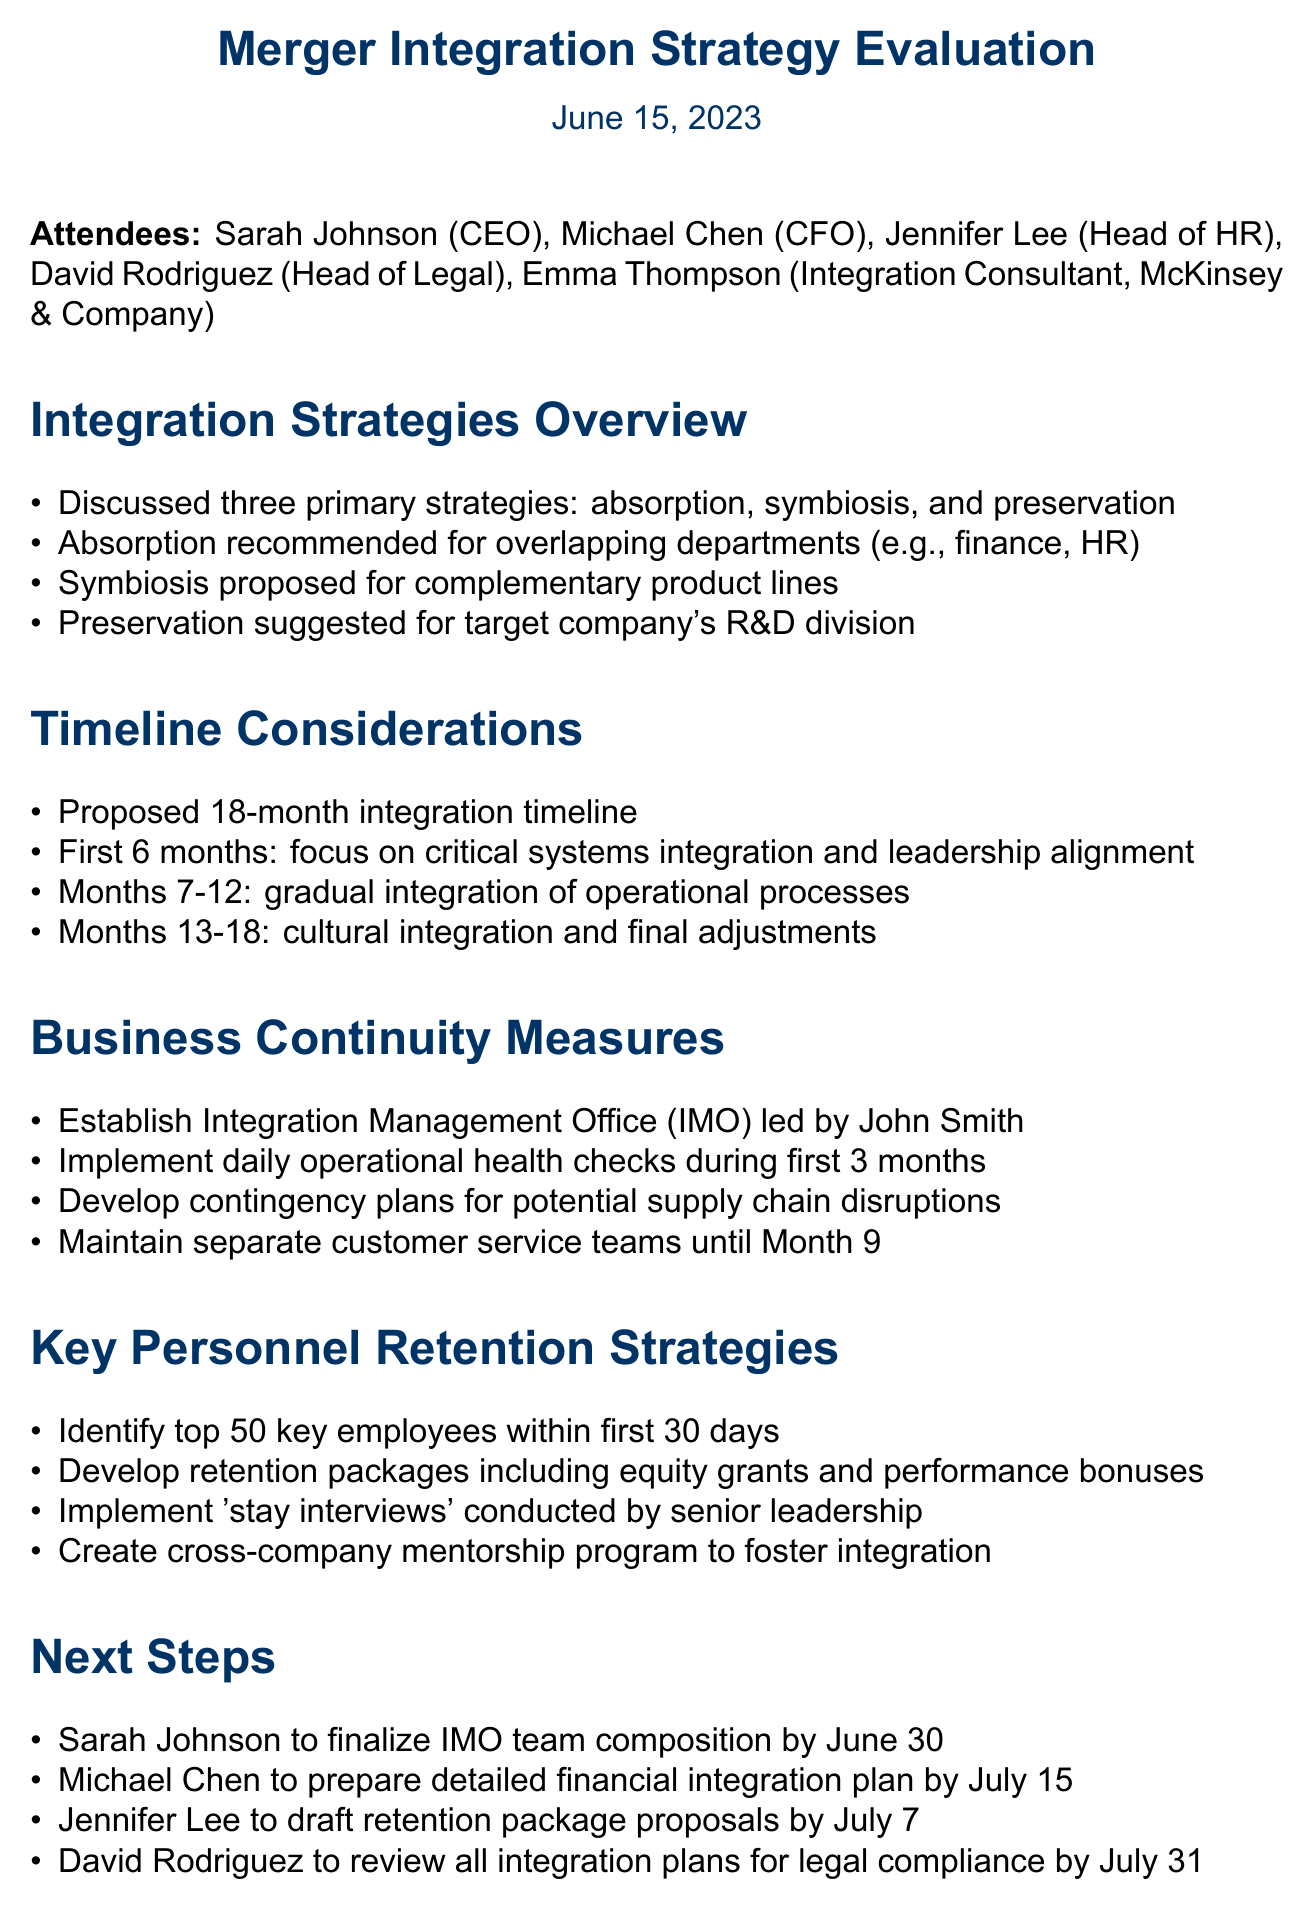what is the meeting title? The meeting title is stated at the beginning of the document as the focus of discussion and provides context.
Answer: Merger Integration Strategy Evaluation who led the Integration Management Office? The document specifies that John Smith is responsible for leading the Integration Management Office, which is crucial for overseeing the integration.
Answer: John Smith what is the proposed integration timeline? The document outlines a timeframe for integration, reflecting the planned steps for merging operations.
Answer: 18 months how many key employees are to be identified? The document mentions a specific number of key employees to focus on for retention, which is essential for maintaining business continuity.
Answer: 50 when is the retention package proposals draft due? The next steps include a deadline for submitting proposals related to retaining key personnel, indicating the urgency of the matter.
Answer: July 7 what are the three primary integration strategies discussed? The document lists the strategies recommended for integration, showcasing the approach to merging the two companies effectively.
Answer: absorption, symbiosis, preservation what is the focus during the first 6 months of integration? The document highlights the initial phase of integration and what themes will dominate those early efforts to ensure smooth operations.
Answer: critical systems integration and leadership alignment what is included in the retention packages? The document describes the content of the retention packages, emphasizing the importance of incentives to keep key staff during the merger.
Answer: equity grants and performance bonuses 